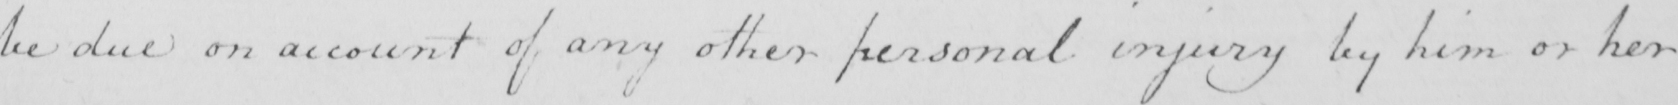What is written in this line of handwriting? be due on account of any other personal injury by him or her 